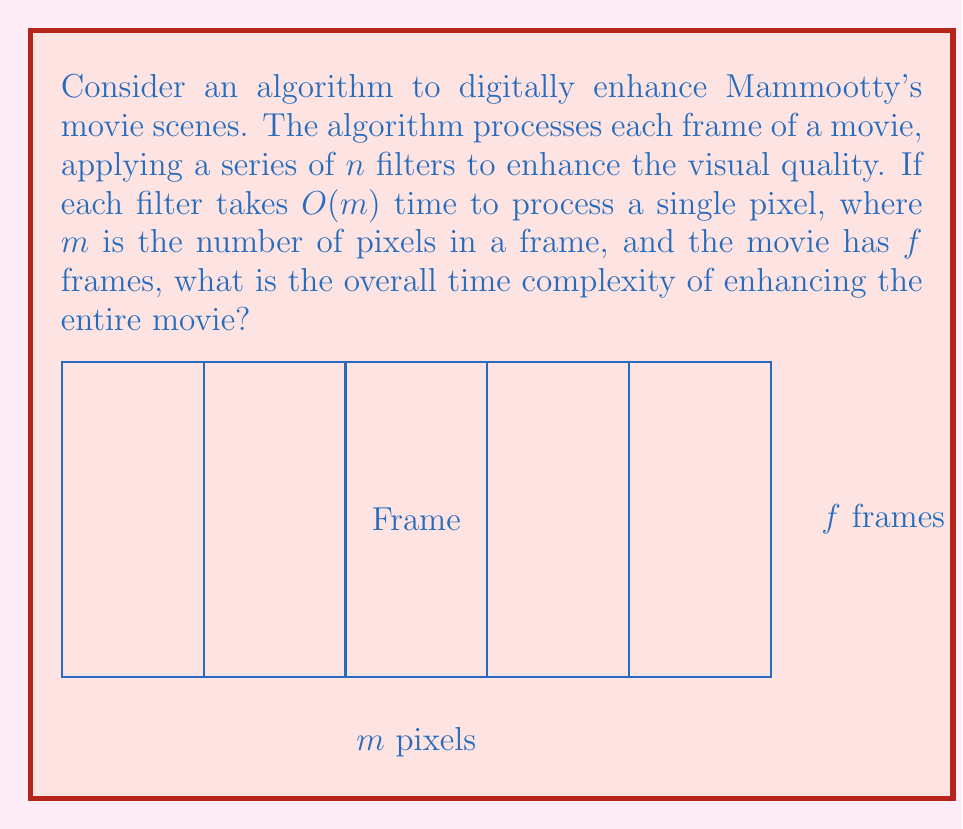Teach me how to tackle this problem. Let's break down the problem step-by-step:

1) First, we need to understand the components of the algorithm:
   - There are $f$ frames in the movie
   - Each frame has $m$ pixels
   - We apply $n$ filters to each frame

2) For a single pixel:
   - Applying one filter takes $O(m)$ time
   - Applying all $n$ filters takes $O(nm)$ time

3) For a single frame:
   - We process $m$ pixels
   - The time complexity for one frame is $O(nm) \cdot m = O(nm^2)$

4) For the entire movie:
   - We process $f$ frames
   - The total time complexity is $O(nm^2) \cdot f = O(fnm^2)$

5) Therefore, the overall time complexity of enhancing the entire movie is $O(fnm^2)$.

This means that the time taken by the algorithm grows linearly with the number of frames and filters, and quadratically with the number of pixels per frame.
Answer: $O(fnm^2)$ 